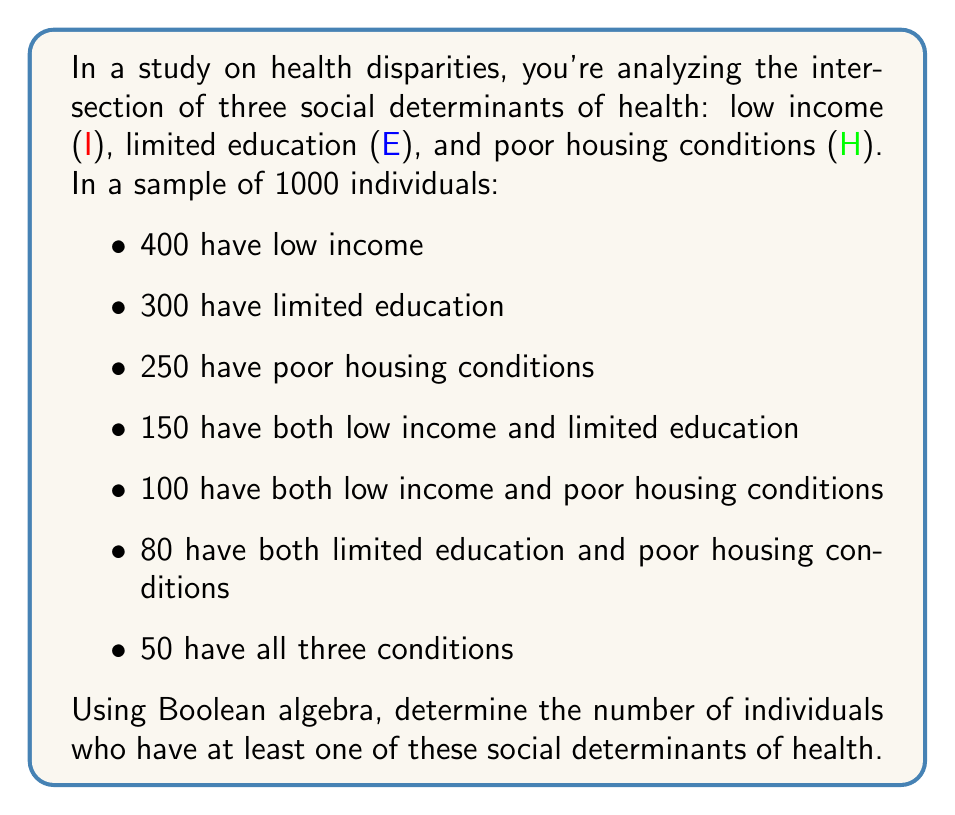What is the answer to this math problem? Let's approach this step-by-step using Boolean algebra and set theory:

1) First, let's define our sets:
   I: individuals with low income
   E: individuals with limited education
   H: individuals with poor housing conditions

2) We need to find $|I \cup E \cup H|$, where $|X|$ denotes the number of elements in set X.

3) We can use the Inclusion-Exclusion Principle:

   $|I \cup E \cup H| = |I| + |E| + |H| - |I \cap E| - |I \cap H| - |E \cap H| + |I \cap E \cap H|$

4) We know:
   $|I| = 400$
   $|E| = 300$
   $|H| = 250$
   $|I \cap E| = 150$
   $|I \cap H| = 100$
   $|E \cap H| = 80$
   $|I \cap E \cap H| = 50$

5) Now, let's substitute these values into our equation:

   $|I \cup E \cup H| = 400 + 300 + 250 - 150 - 100 - 80 + 50$

6) Simplifying:

   $|I \cup E \cup H| = 950 - 280 = 670$

Therefore, 670 individuals have at least one of these social determinants of health.
Answer: 670 